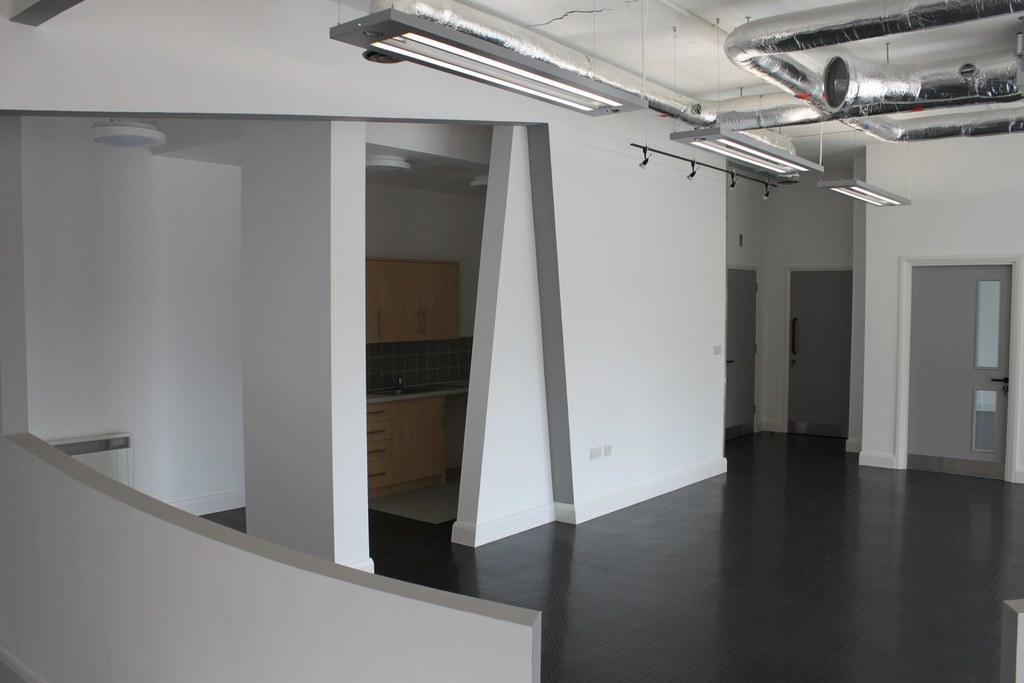What type of location is depicted in the image? The image shows an inside view of a building. Can you identify any specific architectural features in the image? Yes, there is a door, a pillar, and a wall visible in the image. What might be used for illumination in the image? There are lights at the top of the image, which suggests they are used for illumination. How many passengers are waiting in the furniture section of the building in the image? There is no furniture section or passengers present in the image. 